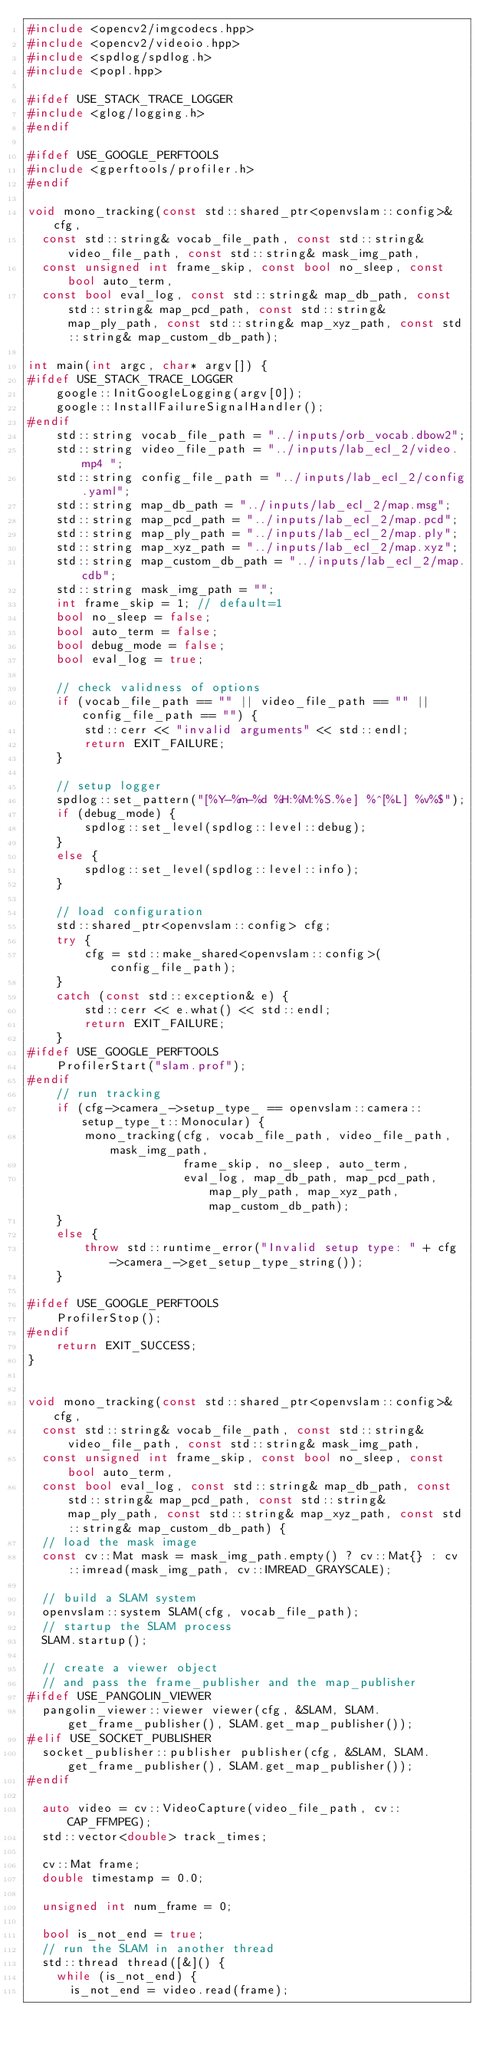<code> <loc_0><loc_0><loc_500><loc_500><_C++_>#include <opencv2/imgcodecs.hpp>
#include <opencv2/videoio.hpp>
#include <spdlog/spdlog.h>
#include <popl.hpp>

#ifdef USE_STACK_TRACE_LOGGER
#include <glog/logging.h>
#endif

#ifdef USE_GOOGLE_PERFTOOLS
#include <gperftools/profiler.h>
#endif

void mono_tracking(const std::shared_ptr<openvslam::config>& cfg,
	const std::string& vocab_file_path, const std::string& video_file_path, const std::string& mask_img_path,
	const unsigned int frame_skip, const bool no_sleep, const bool auto_term,
	const bool eval_log, const std::string& map_db_path, const std::string& map_pcd_path, const std::string& map_ply_path, const std::string& map_xyz_path, const std::string& map_custom_db_path);

int main(int argc, char* argv[]) {
#ifdef USE_STACK_TRACE_LOGGER
    google::InitGoogleLogging(argv[0]);
    google::InstallFailureSignalHandler();
#endif
    std::string vocab_file_path = "../inputs/orb_vocab.dbow2";
    std::string video_file_path = "../inputs/lab_ecl_2/video.mp4 ";
    std::string config_file_path = "../inputs/lab_ecl_2/config.yaml";
    std::string map_db_path = "../inputs/lab_ecl_2/map.msg";
    std::string map_pcd_path = "../inputs/lab_ecl_2/map.pcd";
    std::string map_ply_path = "../inputs/lab_ecl_2/map.ply";
    std::string map_xyz_path = "../inputs/lab_ecl_2/map.xyz";
    std::string map_custom_db_path = "../inputs/lab_ecl_2/map.cdb";
    std::string mask_img_path = "";
    int frame_skip = 1; // default=1
    bool no_sleep = false;
    bool auto_term = false;
    bool debug_mode = false;
    bool eval_log = true;

    // check validness of options
    if (vocab_file_path == "" || video_file_path == "" || config_file_path == "") {
        std::cerr << "invalid arguments" << std::endl;
        return EXIT_FAILURE;
    }

    // setup logger
    spdlog::set_pattern("[%Y-%m-%d %H:%M:%S.%e] %^[%L] %v%$");
    if (debug_mode) {
        spdlog::set_level(spdlog::level::debug);
    }
    else {
        spdlog::set_level(spdlog::level::info);
    }

    // load configuration
    std::shared_ptr<openvslam::config> cfg;
    try {
        cfg = std::make_shared<openvslam::config>(config_file_path);
    }
    catch (const std::exception& e) {
        std::cerr << e.what() << std::endl;
        return EXIT_FAILURE;
    }
#ifdef USE_GOOGLE_PERFTOOLS
    ProfilerStart("slam.prof");
#endif
    // run tracking
    if (cfg->camera_->setup_type_ == openvslam::camera::setup_type_t::Monocular) {
        mono_tracking(cfg, vocab_file_path, video_file_path, mask_img_path,
                      frame_skip, no_sleep, auto_term,
                      eval_log, map_db_path, map_pcd_path, map_ply_path, map_xyz_path, map_custom_db_path);
    }
    else {
        throw std::runtime_error("Invalid setup type: " + cfg->camera_->get_setup_type_string());
    }

#ifdef USE_GOOGLE_PERFTOOLS
    ProfilerStop();
#endif
    return EXIT_SUCCESS;
}


void mono_tracking(const std::shared_ptr<openvslam::config>& cfg,
	const std::string& vocab_file_path, const std::string& video_file_path, const std::string& mask_img_path,
	const unsigned int frame_skip, const bool no_sleep, const bool auto_term,
	const bool eval_log, const std::string& map_db_path, const std::string& map_pcd_path, const std::string& map_ply_path, const std::string& map_xyz_path, const std::string& map_custom_db_path) {
	// load the mask image
	const cv::Mat mask = mask_img_path.empty() ? cv::Mat{} : cv::imread(mask_img_path, cv::IMREAD_GRAYSCALE);

	// build a SLAM system
	openvslam::system SLAM(cfg, vocab_file_path);
	// startup the SLAM process
	SLAM.startup();

	// create a viewer object
	// and pass the frame_publisher and the map_publisher
#ifdef USE_PANGOLIN_VIEWER
	pangolin_viewer::viewer viewer(cfg, &SLAM, SLAM.get_frame_publisher(), SLAM.get_map_publisher());
#elif USE_SOCKET_PUBLISHER
	socket_publisher::publisher publisher(cfg, &SLAM, SLAM.get_frame_publisher(), SLAM.get_map_publisher());
#endif

	auto video = cv::VideoCapture(video_file_path, cv::CAP_FFMPEG);
	std::vector<double> track_times;

	cv::Mat frame;
	double timestamp = 0.0;

	unsigned int num_frame = 0;

	bool is_not_end = true;
	// run the SLAM in another thread
	std::thread thread([&]() {
		while (is_not_end) {
			is_not_end = video.read(frame);
</code> 